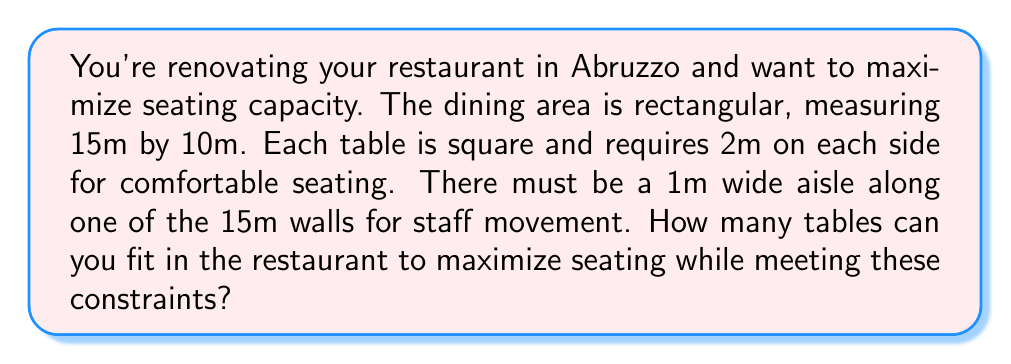Solve this math problem. Let's approach this step-by-step:

1) First, we need to account for the aisle:
   - The usable area becomes 14m x 10m (subtracting 1m for the aisle)

2) Each table, including the space needed around it, occupies a 2m x 2m area.

3) We can fit tables in rows along the 14m side:
   - Number of tables in a row = $\lfloor \frac{14}{2} \rfloor = 7$
   Where $\lfloor \rfloor$ denotes the floor function (rounding down)

4) We can fit tables in columns along the 10m side:
   - Number of tables in a column = $\lfloor \frac{10}{2} \rfloor = 5$

5) Total number of tables = rows * columns
   $$7 * 5 = 35$$

Therefore, the maximum number of tables that can fit in the restaurant while meeting all constraints is 35.

[asy]
unitsize(0.2cm);
draw((0,0)--(75,0)--(75,50)--(0,50)--cycle);
draw((5,0)--(5,50));
for(int i=0; i<7; ++i)
  for(int j=0; j<5; ++j)
    draw((10+i*10,5+j*10)--(20+i*10,5+j*10)--(20+i*10,15+j*10)--(10+i*10,15+j*10)--cycle);
label("15m", (37.5,-5));
label("10m", (-5,25), W);
label("1m", (2.5,25), W);
[/asy]
Answer: 35 tables 